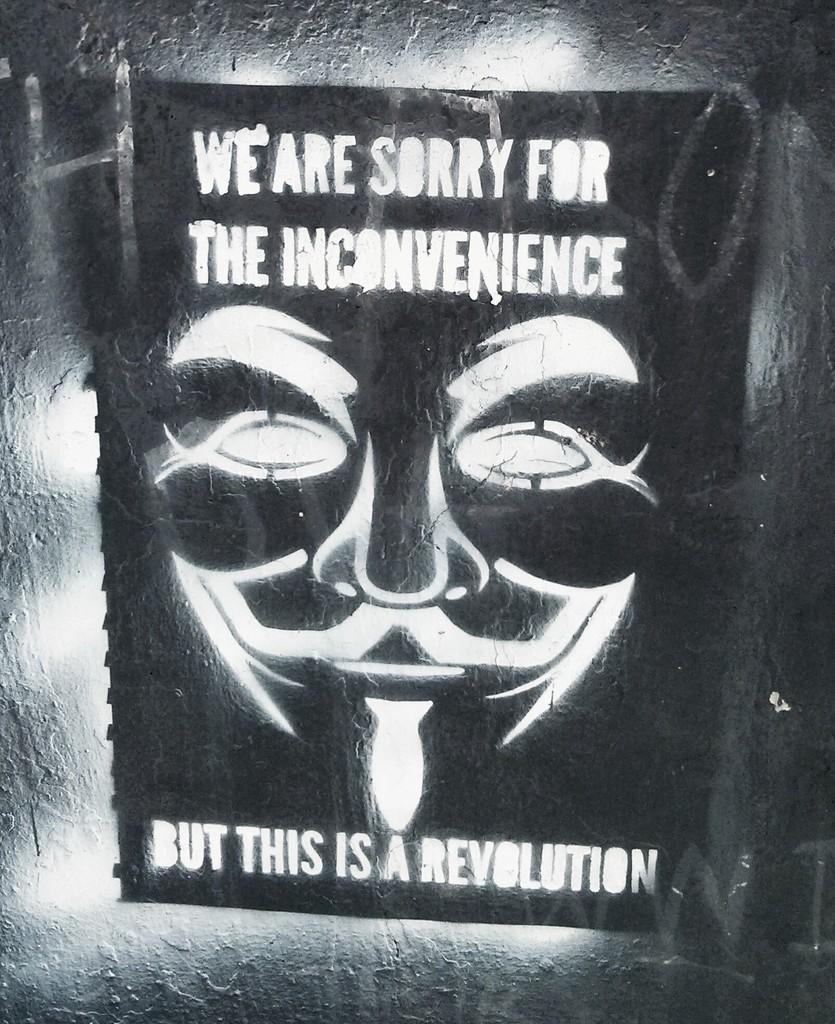In one or two sentences, can you explain what this image depicts? In this image I can see a wall and a notice paper attached the wall, on the paper I can see image of person and text. 